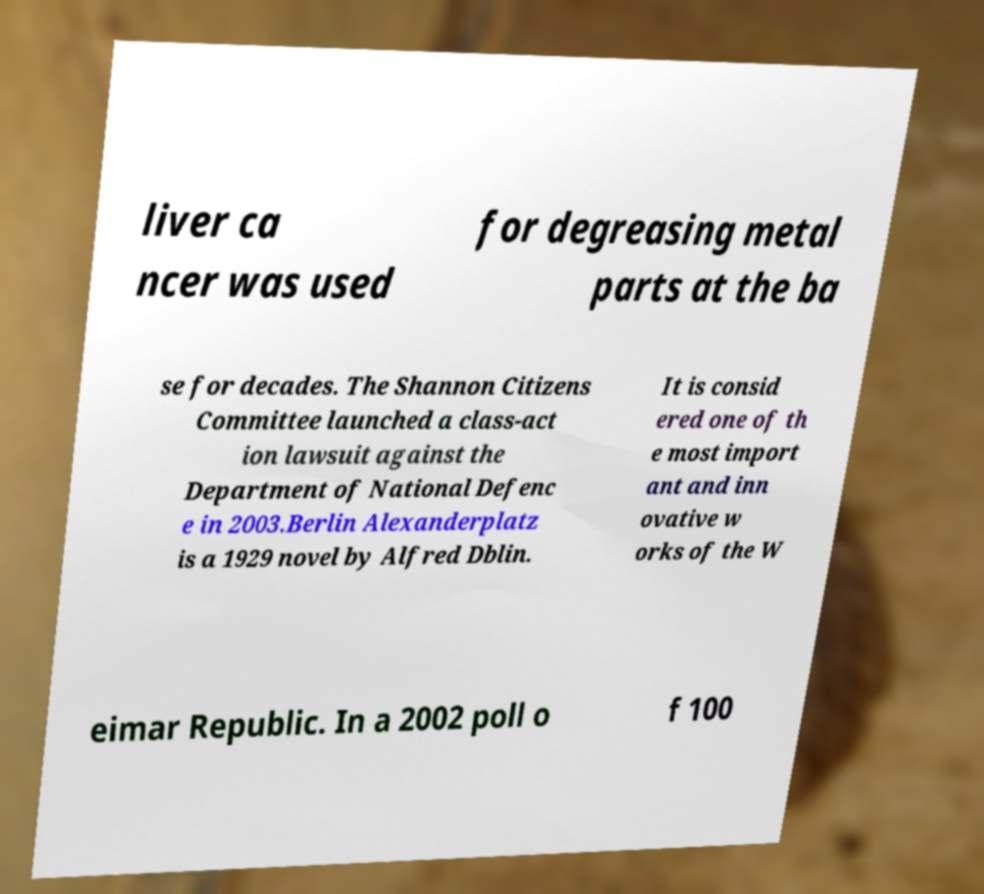For documentation purposes, I need the text within this image transcribed. Could you provide that? liver ca ncer was used for degreasing metal parts at the ba se for decades. The Shannon Citizens Committee launched a class-act ion lawsuit against the Department of National Defenc e in 2003.Berlin Alexanderplatz is a 1929 novel by Alfred Dblin. It is consid ered one of th e most import ant and inn ovative w orks of the W eimar Republic. In a 2002 poll o f 100 